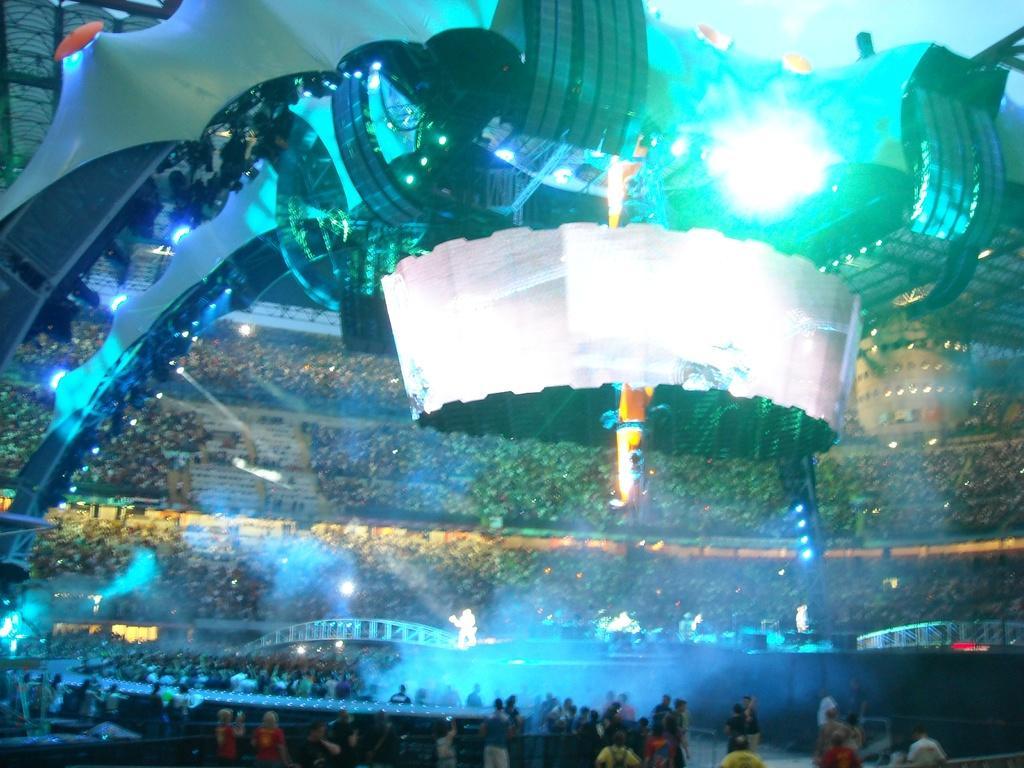Could you give a brief overview of what you see in this image? This is a stadium and here we can see crowd and there are some people standing in the front. At the top, there is an arch and we can see lights and there are railings. 